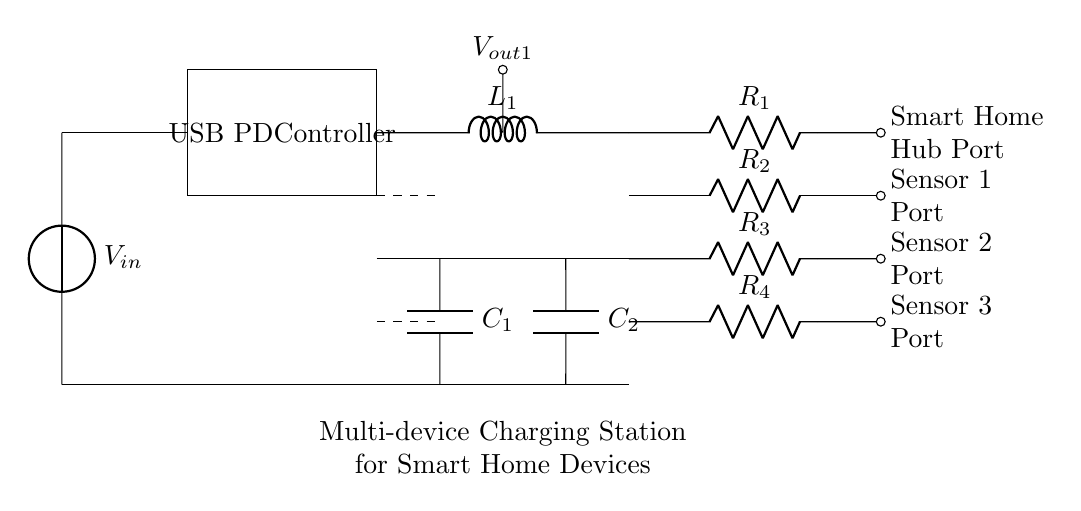What is the input voltage for this circuit? The input voltage is indicated as V sub in, located on the left side of the circuit diagram's power input section.
Answer: V sub in What type of controller is used in this circuit? The component labeled as "USB PD Controller" indicates that the circuit employs a USB Power Delivery controller to manage the power distribution.
Answer: USB PD Controller How many charging ports are available? By counting the indicated ports at the end of the circuit diagram, there are four charging ports labeled for different smart home devices.
Answer: Four What is the role of the buck converter in this circuit? The buck converter is represented in the circuit, which is used to step down the input voltage to a lower output voltage suitable for charging the devices.
Answer: Step down voltage What is the value of the output voltage from the buck converter? The output voltage is denoted as V sub out1 and is connected to the charging ports, implying it provides the necessary voltage to charge the smart home devices.
Answer: V sub out1 What components create the charging ports for the smart devices? The ports are created using resistors labeled R sub 1 to R sub 4, indicating that these resistors are part of the connections to each charging port for the devices.
Answer: Resistors R1, R2, R3, R4 Which element provides filtering in this circuit? The capacitors labeled C sub 1 and C sub 2 are typically used for filtering, smoothing the output voltage from the buck converter to ensure stable charging.
Answer: Capacitors C1, C2 